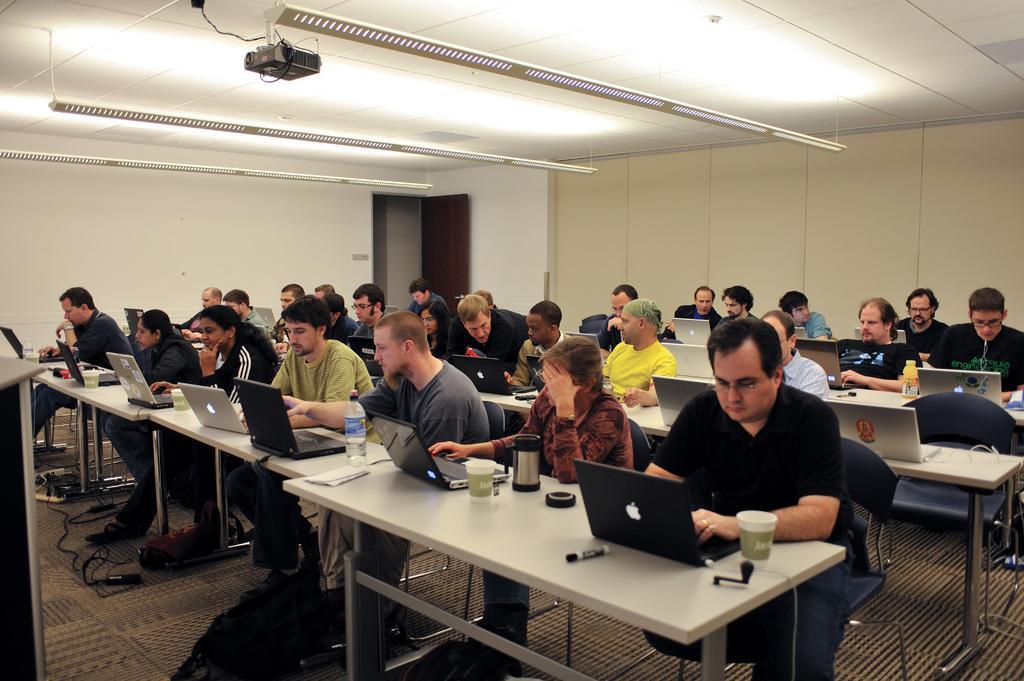Can you describe this image briefly? This picture describes about group of people they are all seated on the chair, in front of them we can see laptops, glasses, bottles, pens on the table, on top of them we can see projector and metal rods. 